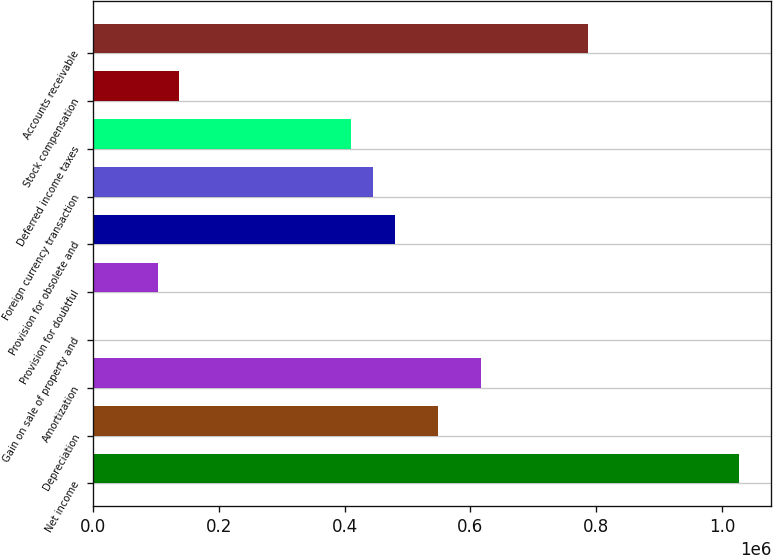<chart> <loc_0><loc_0><loc_500><loc_500><bar_chart><fcel>Net income<fcel>Depreciation<fcel>Amortization<fcel>Gain on sale of property and<fcel>Provision for doubtful<fcel>Provision for obsolete and<fcel>Foreign currency transaction<fcel>Deferred income taxes<fcel>Stock compensation<fcel>Accounts receivable<nl><fcel>1.027e+06<fcel>547752<fcel>616217<fcel>37<fcel>102734<fcel>479288<fcel>445056<fcel>410823<fcel>136966<fcel>787378<nl></chart> 